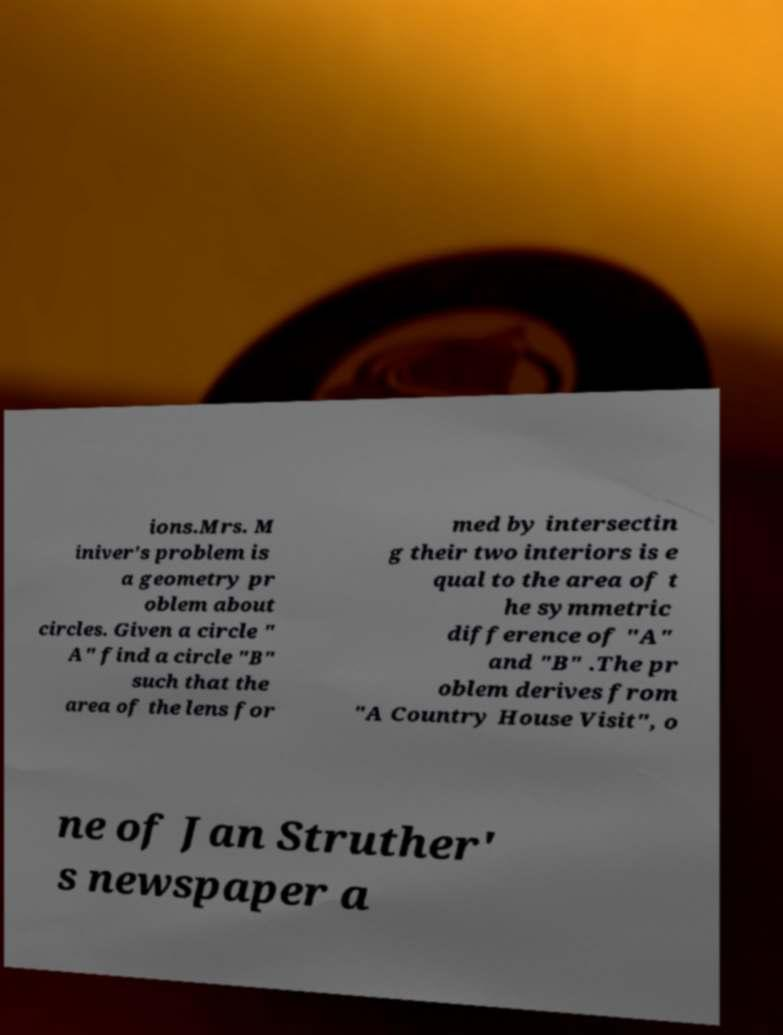Can you read and provide the text displayed in the image?This photo seems to have some interesting text. Can you extract and type it out for me? ions.Mrs. M iniver's problem is a geometry pr oblem about circles. Given a circle " A" find a circle "B" such that the area of the lens for med by intersectin g their two interiors is e qual to the area of t he symmetric difference of "A" and "B" .The pr oblem derives from "A Country House Visit", o ne of Jan Struther' s newspaper a 